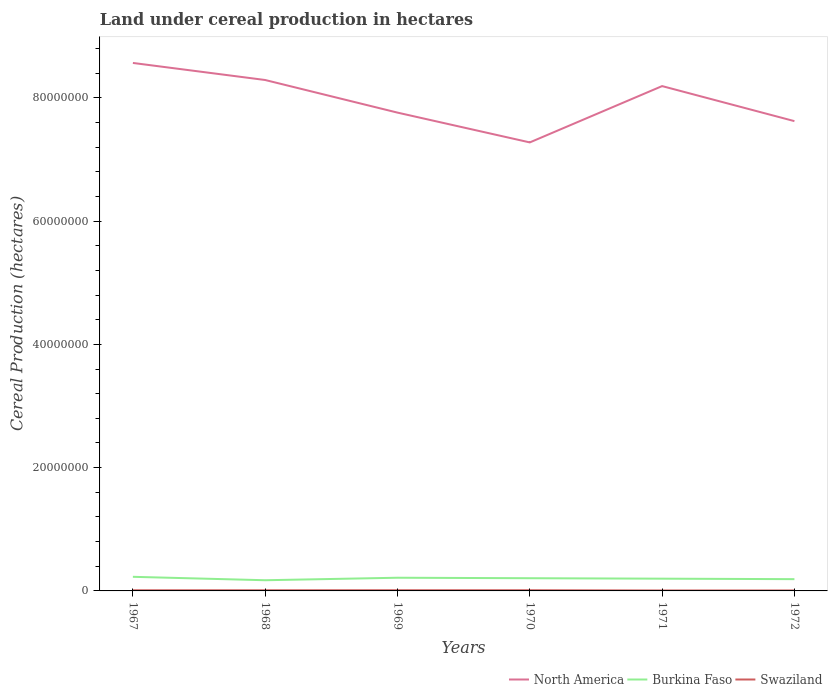Is the number of lines equal to the number of legend labels?
Give a very brief answer. Yes. Across all years, what is the maximum land under cereal production in Burkina Faso?
Your answer should be very brief. 1.73e+06. What is the total land under cereal production in Swaziland in the graph?
Ensure brevity in your answer.  4.04e+04. What is the difference between the highest and the second highest land under cereal production in North America?
Your answer should be compact. 1.29e+07. What is the difference between the highest and the lowest land under cereal production in North America?
Your answer should be very brief. 3. How many lines are there?
Give a very brief answer. 3. How many years are there in the graph?
Offer a terse response. 6. Are the values on the major ticks of Y-axis written in scientific E-notation?
Your response must be concise. No. Does the graph contain grids?
Make the answer very short. No. How many legend labels are there?
Make the answer very short. 3. What is the title of the graph?
Keep it short and to the point. Land under cereal production in hectares. What is the label or title of the Y-axis?
Keep it short and to the point. Cereal Production (hectares). What is the Cereal Production (hectares) in North America in 1967?
Your answer should be very brief. 8.57e+07. What is the Cereal Production (hectares) of Burkina Faso in 1967?
Your response must be concise. 2.29e+06. What is the Cereal Production (hectares) in Swaziland in 1967?
Make the answer very short. 1.03e+05. What is the Cereal Production (hectares) of North America in 1968?
Offer a very short reply. 8.29e+07. What is the Cereal Production (hectares) of Burkina Faso in 1968?
Offer a terse response. 1.73e+06. What is the Cereal Production (hectares) in Swaziland in 1968?
Make the answer very short. 1.07e+05. What is the Cereal Production (hectares) in North America in 1969?
Keep it short and to the point. 7.76e+07. What is the Cereal Production (hectares) in Burkina Faso in 1969?
Offer a very short reply. 2.14e+06. What is the Cereal Production (hectares) in Swaziland in 1969?
Make the answer very short. 1.11e+05. What is the Cereal Production (hectares) in North America in 1970?
Offer a terse response. 7.28e+07. What is the Cereal Production (hectares) of Burkina Faso in 1970?
Provide a succinct answer. 2.06e+06. What is the Cereal Production (hectares) of Swaziland in 1970?
Make the answer very short. 1.12e+05. What is the Cereal Production (hectares) of North America in 1971?
Provide a succinct answer. 8.19e+07. What is the Cereal Production (hectares) in Burkina Faso in 1971?
Make the answer very short. 1.99e+06. What is the Cereal Production (hectares) in Swaziland in 1971?
Ensure brevity in your answer.  7.19e+04. What is the Cereal Production (hectares) of North America in 1972?
Your answer should be compact. 7.62e+07. What is the Cereal Production (hectares) of Burkina Faso in 1972?
Provide a short and direct response. 1.91e+06. What is the Cereal Production (hectares) of Swaziland in 1972?
Offer a terse response. 7.41e+04. Across all years, what is the maximum Cereal Production (hectares) of North America?
Provide a short and direct response. 8.57e+07. Across all years, what is the maximum Cereal Production (hectares) in Burkina Faso?
Offer a terse response. 2.29e+06. Across all years, what is the maximum Cereal Production (hectares) in Swaziland?
Keep it short and to the point. 1.12e+05. Across all years, what is the minimum Cereal Production (hectares) of North America?
Keep it short and to the point. 7.28e+07. Across all years, what is the minimum Cereal Production (hectares) of Burkina Faso?
Ensure brevity in your answer.  1.73e+06. Across all years, what is the minimum Cereal Production (hectares) in Swaziland?
Give a very brief answer. 7.19e+04. What is the total Cereal Production (hectares) in North America in the graph?
Your response must be concise. 4.77e+08. What is the total Cereal Production (hectares) in Burkina Faso in the graph?
Provide a succinct answer. 1.21e+07. What is the total Cereal Production (hectares) of Swaziland in the graph?
Provide a succinct answer. 5.80e+05. What is the difference between the Cereal Production (hectares) of North America in 1967 and that in 1968?
Offer a terse response. 2.77e+06. What is the difference between the Cereal Production (hectares) of Burkina Faso in 1967 and that in 1968?
Keep it short and to the point. 5.55e+05. What is the difference between the Cereal Production (hectares) in Swaziland in 1967 and that in 1968?
Make the answer very short. -4171. What is the difference between the Cereal Production (hectares) of North America in 1967 and that in 1969?
Offer a very short reply. 8.06e+06. What is the difference between the Cereal Production (hectares) in Burkina Faso in 1967 and that in 1969?
Provide a short and direct response. 1.48e+05. What is the difference between the Cereal Production (hectares) of Swaziland in 1967 and that in 1969?
Offer a terse response. -7265. What is the difference between the Cereal Production (hectares) in North America in 1967 and that in 1970?
Offer a terse response. 1.29e+07. What is the difference between the Cereal Production (hectares) in Burkina Faso in 1967 and that in 1970?
Your answer should be compact. 2.27e+05. What is the difference between the Cereal Production (hectares) in Swaziland in 1967 and that in 1970?
Ensure brevity in your answer.  -8963. What is the difference between the Cereal Production (hectares) in North America in 1967 and that in 1971?
Make the answer very short. 3.75e+06. What is the difference between the Cereal Production (hectares) of Burkina Faso in 1967 and that in 1971?
Give a very brief answer. 3.00e+05. What is the difference between the Cereal Production (hectares) in Swaziland in 1967 and that in 1971?
Your response must be concise. 3.14e+04. What is the difference between the Cereal Production (hectares) of North America in 1967 and that in 1972?
Offer a terse response. 9.44e+06. What is the difference between the Cereal Production (hectares) in Burkina Faso in 1967 and that in 1972?
Your answer should be compact. 3.80e+05. What is the difference between the Cereal Production (hectares) of Swaziland in 1967 and that in 1972?
Your response must be concise. 2.92e+04. What is the difference between the Cereal Production (hectares) of North America in 1968 and that in 1969?
Give a very brief answer. 5.29e+06. What is the difference between the Cereal Production (hectares) in Burkina Faso in 1968 and that in 1969?
Offer a very short reply. -4.07e+05. What is the difference between the Cereal Production (hectares) of Swaziland in 1968 and that in 1969?
Offer a very short reply. -3094. What is the difference between the Cereal Production (hectares) in North America in 1968 and that in 1970?
Provide a succinct answer. 1.01e+07. What is the difference between the Cereal Production (hectares) of Burkina Faso in 1968 and that in 1970?
Your response must be concise. -3.29e+05. What is the difference between the Cereal Production (hectares) in Swaziland in 1968 and that in 1970?
Make the answer very short. -4792. What is the difference between the Cereal Production (hectares) in North America in 1968 and that in 1971?
Offer a very short reply. 9.86e+05. What is the difference between the Cereal Production (hectares) in Burkina Faso in 1968 and that in 1971?
Ensure brevity in your answer.  -2.55e+05. What is the difference between the Cereal Production (hectares) in Swaziland in 1968 and that in 1971?
Your answer should be very brief. 3.56e+04. What is the difference between the Cereal Production (hectares) in North America in 1968 and that in 1972?
Provide a short and direct response. 6.67e+06. What is the difference between the Cereal Production (hectares) in Burkina Faso in 1968 and that in 1972?
Offer a terse response. -1.75e+05. What is the difference between the Cereal Production (hectares) of Swaziland in 1968 and that in 1972?
Make the answer very short. 3.34e+04. What is the difference between the Cereal Production (hectares) in North America in 1969 and that in 1970?
Make the answer very short. 4.83e+06. What is the difference between the Cereal Production (hectares) of Burkina Faso in 1969 and that in 1970?
Your response must be concise. 7.86e+04. What is the difference between the Cereal Production (hectares) of Swaziland in 1969 and that in 1970?
Offer a very short reply. -1698. What is the difference between the Cereal Production (hectares) in North America in 1969 and that in 1971?
Give a very brief answer. -4.30e+06. What is the difference between the Cereal Production (hectares) in Burkina Faso in 1969 and that in 1971?
Give a very brief answer. 1.52e+05. What is the difference between the Cereal Production (hectares) of Swaziland in 1969 and that in 1971?
Provide a succinct answer. 3.87e+04. What is the difference between the Cereal Production (hectares) in North America in 1969 and that in 1972?
Ensure brevity in your answer.  1.38e+06. What is the difference between the Cereal Production (hectares) in Burkina Faso in 1969 and that in 1972?
Offer a very short reply. 2.32e+05. What is the difference between the Cereal Production (hectares) of Swaziland in 1969 and that in 1972?
Your response must be concise. 3.65e+04. What is the difference between the Cereal Production (hectares) of North America in 1970 and that in 1971?
Keep it short and to the point. -9.14e+06. What is the difference between the Cereal Production (hectares) in Burkina Faso in 1970 and that in 1971?
Give a very brief answer. 7.38e+04. What is the difference between the Cereal Production (hectares) in Swaziland in 1970 and that in 1971?
Ensure brevity in your answer.  4.04e+04. What is the difference between the Cereal Production (hectares) in North America in 1970 and that in 1972?
Offer a terse response. -3.45e+06. What is the difference between the Cereal Production (hectares) in Burkina Faso in 1970 and that in 1972?
Your response must be concise. 1.53e+05. What is the difference between the Cereal Production (hectares) in Swaziland in 1970 and that in 1972?
Offer a very short reply. 3.82e+04. What is the difference between the Cereal Production (hectares) in North America in 1971 and that in 1972?
Offer a terse response. 5.68e+06. What is the difference between the Cereal Production (hectares) of Burkina Faso in 1971 and that in 1972?
Your response must be concise. 7.95e+04. What is the difference between the Cereal Production (hectares) in Swaziland in 1971 and that in 1972?
Your response must be concise. -2229. What is the difference between the Cereal Production (hectares) in North America in 1967 and the Cereal Production (hectares) in Burkina Faso in 1968?
Provide a succinct answer. 8.39e+07. What is the difference between the Cereal Production (hectares) in North America in 1967 and the Cereal Production (hectares) in Swaziland in 1968?
Your answer should be very brief. 8.55e+07. What is the difference between the Cereal Production (hectares) of Burkina Faso in 1967 and the Cereal Production (hectares) of Swaziland in 1968?
Make the answer very short. 2.18e+06. What is the difference between the Cereal Production (hectares) in North America in 1967 and the Cereal Production (hectares) in Burkina Faso in 1969?
Ensure brevity in your answer.  8.35e+07. What is the difference between the Cereal Production (hectares) of North America in 1967 and the Cereal Production (hectares) of Swaziland in 1969?
Your answer should be very brief. 8.55e+07. What is the difference between the Cereal Production (hectares) of Burkina Faso in 1967 and the Cereal Production (hectares) of Swaziland in 1969?
Your answer should be very brief. 2.18e+06. What is the difference between the Cereal Production (hectares) of North America in 1967 and the Cereal Production (hectares) of Burkina Faso in 1970?
Your answer should be compact. 8.36e+07. What is the difference between the Cereal Production (hectares) in North America in 1967 and the Cereal Production (hectares) in Swaziland in 1970?
Make the answer very short. 8.55e+07. What is the difference between the Cereal Production (hectares) in Burkina Faso in 1967 and the Cereal Production (hectares) in Swaziland in 1970?
Offer a terse response. 2.18e+06. What is the difference between the Cereal Production (hectares) in North America in 1967 and the Cereal Production (hectares) in Burkina Faso in 1971?
Keep it short and to the point. 8.37e+07. What is the difference between the Cereal Production (hectares) in North America in 1967 and the Cereal Production (hectares) in Swaziland in 1971?
Provide a short and direct response. 8.56e+07. What is the difference between the Cereal Production (hectares) in Burkina Faso in 1967 and the Cereal Production (hectares) in Swaziland in 1971?
Offer a very short reply. 2.22e+06. What is the difference between the Cereal Production (hectares) of North America in 1967 and the Cereal Production (hectares) of Burkina Faso in 1972?
Provide a short and direct response. 8.37e+07. What is the difference between the Cereal Production (hectares) of North America in 1967 and the Cereal Production (hectares) of Swaziland in 1972?
Provide a short and direct response. 8.56e+07. What is the difference between the Cereal Production (hectares) in Burkina Faso in 1967 and the Cereal Production (hectares) in Swaziland in 1972?
Your answer should be very brief. 2.21e+06. What is the difference between the Cereal Production (hectares) in North America in 1968 and the Cereal Production (hectares) in Burkina Faso in 1969?
Your answer should be very brief. 8.07e+07. What is the difference between the Cereal Production (hectares) in North America in 1968 and the Cereal Production (hectares) in Swaziland in 1969?
Provide a short and direct response. 8.28e+07. What is the difference between the Cereal Production (hectares) in Burkina Faso in 1968 and the Cereal Production (hectares) in Swaziland in 1969?
Offer a very short reply. 1.62e+06. What is the difference between the Cereal Production (hectares) of North America in 1968 and the Cereal Production (hectares) of Burkina Faso in 1970?
Give a very brief answer. 8.08e+07. What is the difference between the Cereal Production (hectares) in North America in 1968 and the Cereal Production (hectares) in Swaziland in 1970?
Offer a terse response. 8.28e+07. What is the difference between the Cereal Production (hectares) of Burkina Faso in 1968 and the Cereal Production (hectares) of Swaziland in 1970?
Offer a very short reply. 1.62e+06. What is the difference between the Cereal Production (hectares) of North America in 1968 and the Cereal Production (hectares) of Burkina Faso in 1971?
Offer a very short reply. 8.09e+07. What is the difference between the Cereal Production (hectares) of North America in 1968 and the Cereal Production (hectares) of Swaziland in 1971?
Your answer should be compact. 8.28e+07. What is the difference between the Cereal Production (hectares) in Burkina Faso in 1968 and the Cereal Production (hectares) in Swaziland in 1971?
Offer a terse response. 1.66e+06. What is the difference between the Cereal Production (hectares) of North America in 1968 and the Cereal Production (hectares) of Burkina Faso in 1972?
Make the answer very short. 8.10e+07. What is the difference between the Cereal Production (hectares) of North America in 1968 and the Cereal Production (hectares) of Swaziland in 1972?
Your answer should be very brief. 8.28e+07. What is the difference between the Cereal Production (hectares) in Burkina Faso in 1968 and the Cereal Production (hectares) in Swaziland in 1972?
Give a very brief answer. 1.66e+06. What is the difference between the Cereal Production (hectares) in North America in 1969 and the Cereal Production (hectares) in Burkina Faso in 1970?
Offer a terse response. 7.55e+07. What is the difference between the Cereal Production (hectares) in North America in 1969 and the Cereal Production (hectares) in Swaziland in 1970?
Ensure brevity in your answer.  7.75e+07. What is the difference between the Cereal Production (hectares) of Burkina Faso in 1969 and the Cereal Production (hectares) of Swaziland in 1970?
Your answer should be very brief. 2.03e+06. What is the difference between the Cereal Production (hectares) of North America in 1969 and the Cereal Production (hectares) of Burkina Faso in 1971?
Offer a terse response. 7.56e+07. What is the difference between the Cereal Production (hectares) in North America in 1969 and the Cereal Production (hectares) in Swaziland in 1971?
Your response must be concise. 7.75e+07. What is the difference between the Cereal Production (hectares) in Burkina Faso in 1969 and the Cereal Production (hectares) in Swaziland in 1971?
Your answer should be very brief. 2.07e+06. What is the difference between the Cereal Production (hectares) of North America in 1969 and the Cereal Production (hectares) of Burkina Faso in 1972?
Provide a succinct answer. 7.57e+07. What is the difference between the Cereal Production (hectares) of North America in 1969 and the Cereal Production (hectares) of Swaziland in 1972?
Your answer should be compact. 7.75e+07. What is the difference between the Cereal Production (hectares) of Burkina Faso in 1969 and the Cereal Production (hectares) of Swaziland in 1972?
Offer a very short reply. 2.07e+06. What is the difference between the Cereal Production (hectares) of North America in 1970 and the Cereal Production (hectares) of Burkina Faso in 1971?
Offer a very short reply. 7.08e+07. What is the difference between the Cereal Production (hectares) in North America in 1970 and the Cereal Production (hectares) in Swaziland in 1971?
Ensure brevity in your answer.  7.27e+07. What is the difference between the Cereal Production (hectares) of Burkina Faso in 1970 and the Cereal Production (hectares) of Swaziland in 1971?
Provide a short and direct response. 1.99e+06. What is the difference between the Cereal Production (hectares) in North America in 1970 and the Cereal Production (hectares) in Burkina Faso in 1972?
Ensure brevity in your answer.  7.09e+07. What is the difference between the Cereal Production (hectares) in North America in 1970 and the Cereal Production (hectares) in Swaziland in 1972?
Provide a short and direct response. 7.27e+07. What is the difference between the Cereal Production (hectares) of Burkina Faso in 1970 and the Cereal Production (hectares) of Swaziland in 1972?
Provide a succinct answer. 1.99e+06. What is the difference between the Cereal Production (hectares) of North America in 1971 and the Cereal Production (hectares) of Burkina Faso in 1972?
Offer a very short reply. 8.00e+07. What is the difference between the Cereal Production (hectares) of North America in 1971 and the Cereal Production (hectares) of Swaziland in 1972?
Provide a short and direct response. 8.18e+07. What is the difference between the Cereal Production (hectares) in Burkina Faso in 1971 and the Cereal Production (hectares) in Swaziland in 1972?
Your response must be concise. 1.91e+06. What is the average Cereal Production (hectares) of North America per year?
Your response must be concise. 7.95e+07. What is the average Cereal Production (hectares) of Burkina Faso per year?
Make the answer very short. 2.02e+06. What is the average Cereal Production (hectares) of Swaziland per year?
Your response must be concise. 9.66e+04. In the year 1967, what is the difference between the Cereal Production (hectares) in North America and Cereal Production (hectares) in Burkina Faso?
Give a very brief answer. 8.34e+07. In the year 1967, what is the difference between the Cereal Production (hectares) of North America and Cereal Production (hectares) of Swaziland?
Your response must be concise. 8.55e+07. In the year 1967, what is the difference between the Cereal Production (hectares) in Burkina Faso and Cereal Production (hectares) in Swaziland?
Offer a terse response. 2.19e+06. In the year 1968, what is the difference between the Cereal Production (hectares) in North America and Cereal Production (hectares) in Burkina Faso?
Give a very brief answer. 8.11e+07. In the year 1968, what is the difference between the Cereal Production (hectares) of North America and Cereal Production (hectares) of Swaziland?
Offer a very short reply. 8.28e+07. In the year 1968, what is the difference between the Cereal Production (hectares) of Burkina Faso and Cereal Production (hectares) of Swaziland?
Provide a succinct answer. 1.63e+06. In the year 1969, what is the difference between the Cereal Production (hectares) of North America and Cereal Production (hectares) of Burkina Faso?
Your answer should be very brief. 7.55e+07. In the year 1969, what is the difference between the Cereal Production (hectares) in North America and Cereal Production (hectares) in Swaziland?
Provide a succinct answer. 7.75e+07. In the year 1969, what is the difference between the Cereal Production (hectares) in Burkina Faso and Cereal Production (hectares) in Swaziland?
Provide a short and direct response. 2.03e+06. In the year 1970, what is the difference between the Cereal Production (hectares) of North America and Cereal Production (hectares) of Burkina Faso?
Your answer should be compact. 7.07e+07. In the year 1970, what is the difference between the Cereal Production (hectares) of North America and Cereal Production (hectares) of Swaziland?
Provide a succinct answer. 7.26e+07. In the year 1970, what is the difference between the Cereal Production (hectares) of Burkina Faso and Cereal Production (hectares) of Swaziland?
Make the answer very short. 1.95e+06. In the year 1971, what is the difference between the Cereal Production (hectares) of North America and Cereal Production (hectares) of Burkina Faso?
Offer a terse response. 7.99e+07. In the year 1971, what is the difference between the Cereal Production (hectares) in North America and Cereal Production (hectares) in Swaziland?
Keep it short and to the point. 8.18e+07. In the year 1971, what is the difference between the Cereal Production (hectares) of Burkina Faso and Cereal Production (hectares) of Swaziland?
Offer a terse response. 1.92e+06. In the year 1972, what is the difference between the Cereal Production (hectares) of North America and Cereal Production (hectares) of Burkina Faso?
Make the answer very short. 7.43e+07. In the year 1972, what is the difference between the Cereal Production (hectares) of North America and Cereal Production (hectares) of Swaziland?
Provide a succinct answer. 7.61e+07. In the year 1972, what is the difference between the Cereal Production (hectares) in Burkina Faso and Cereal Production (hectares) in Swaziland?
Offer a terse response. 1.83e+06. What is the ratio of the Cereal Production (hectares) in North America in 1967 to that in 1968?
Your answer should be very brief. 1.03. What is the ratio of the Cereal Production (hectares) in Burkina Faso in 1967 to that in 1968?
Give a very brief answer. 1.32. What is the ratio of the Cereal Production (hectares) in Swaziland in 1967 to that in 1968?
Offer a terse response. 0.96. What is the ratio of the Cereal Production (hectares) of North America in 1967 to that in 1969?
Your answer should be very brief. 1.1. What is the ratio of the Cereal Production (hectares) of Burkina Faso in 1967 to that in 1969?
Your response must be concise. 1.07. What is the ratio of the Cereal Production (hectares) of Swaziland in 1967 to that in 1969?
Offer a terse response. 0.93. What is the ratio of the Cereal Production (hectares) of North America in 1967 to that in 1970?
Your answer should be compact. 1.18. What is the ratio of the Cereal Production (hectares) in Burkina Faso in 1967 to that in 1970?
Your response must be concise. 1.11. What is the ratio of the Cereal Production (hectares) in Swaziland in 1967 to that in 1970?
Your answer should be compact. 0.92. What is the ratio of the Cereal Production (hectares) of North America in 1967 to that in 1971?
Offer a very short reply. 1.05. What is the ratio of the Cereal Production (hectares) in Burkina Faso in 1967 to that in 1971?
Your answer should be compact. 1.15. What is the ratio of the Cereal Production (hectares) in Swaziland in 1967 to that in 1971?
Offer a very short reply. 1.44. What is the ratio of the Cereal Production (hectares) of North America in 1967 to that in 1972?
Provide a short and direct response. 1.12. What is the ratio of the Cereal Production (hectares) of Burkina Faso in 1967 to that in 1972?
Offer a terse response. 1.2. What is the ratio of the Cereal Production (hectares) of Swaziland in 1967 to that in 1972?
Offer a very short reply. 1.39. What is the ratio of the Cereal Production (hectares) in North America in 1968 to that in 1969?
Offer a terse response. 1.07. What is the ratio of the Cereal Production (hectares) in Burkina Faso in 1968 to that in 1969?
Offer a very short reply. 0.81. What is the ratio of the Cereal Production (hectares) of North America in 1968 to that in 1970?
Ensure brevity in your answer.  1.14. What is the ratio of the Cereal Production (hectares) of Burkina Faso in 1968 to that in 1970?
Offer a terse response. 0.84. What is the ratio of the Cereal Production (hectares) of Swaziland in 1968 to that in 1970?
Provide a short and direct response. 0.96. What is the ratio of the Cereal Production (hectares) of North America in 1968 to that in 1971?
Provide a succinct answer. 1.01. What is the ratio of the Cereal Production (hectares) of Burkina Faso in 1968 to that in 1971?
Provide a succinct answer. 0.87. What is the ratio of the Cereal Production (hectares) of Swaziland in 1968 to that in 1971?
Give a very brief answer. 1.5. What is the ratio of the Cereal Production (hectares) of North America in 1968 to that in 1972?
Ensure brevity in your answer.  1.09. What is the ratio of the Cereal Production (hectares) of Burkina Faso in 1968 to that in 1972?
Your answer should be compact. 0.91. What is the ratio of the Cereal Production (hectares) of Swaziland in 1968 to that in 1972?
Keep it short and to the point. 1.45. What is the ratio of the Cereal Production (hectares) in North America in 1969 to that in 1970?
Keep it short and to the point. 1.07. What is the ratio of the Cereal Production (hectares) in Burkina Faso in 1969 to that in 1970?
Ensure brevity in your answer.  1.04. What is the ratio of the Cereal Production (hectares) in Swaziland in 1969 to that in 1970?
Your answer should be very brief. 0.98. What is the ratio of the Cereal Production (hectares) of North America in 1969 to that in 1971?
Ensure brevity in your answer.  0.95. What is the ratio of the Cereal Production (hectares) in Burkina Faso in 1969 to that in 1971?
Make the answer very short. 1.08. What is the ratio of the Cereal Production (hectares) in Swaziland in 1969 to that in 1971?
Make the answer very short. 1.54. What is the ratio of the Cereal Production (hectares) in North America in 1969 to that in 1972?
Give a very brief answer. 1.02. What is the ratio of the Cereal Production (hectares) of Burkina Faso in 1969 to that in 1972?
Offer a terse response. 1.12. What is the ratio of the Cereal Production (hectares) in Swaziland in 1969 to that in 1972?
Your response must be concise. 1.49. What is the ratio of the Cereal Production (hectares) in North America in 1970 to that in 1971?
Give a very brief answer. 0.89. What is the ratio of the Cereal Production (hectares) in Burkina Faso in 1970 to that in 1971?
Your answer should be very brief. 1.04. What is the ratio of the Cereal Production (hectares) in Swaziland in 1970 to that in 1971?
Your response must be concise. 1.56. What is the ratio of the Cereal Production (hectares) of North America in 1970 to that in 1972?
Provide a short and direct response. 0.95. What is the ratio of the Cereal Production (hectares) of Burkina Faso in 1970 to that in 1972?
Your response must be concise. 1.08. What is the ratio of the Cereal Production (hectares) in Swaziland in 1970 to that in 1972?
Provide a short and direct response. 1.52. What is the ratio of the Cereal Production (hectares) of North America in 1971 to that in 1972?
Ensure brevity in your answer.  1.07. What is the ratio of the Cereal Production (hectares) in Burkina Faso in 1971 to that in 1972?
Your answer should be very brief. 1.04. What is the ratio of the Cereal Production (hectares) of Swaziland in 1971 to that in 1972?
Make the answer very short. 0.97. What is the difference between the highest and the second highest Cereal Production (hectares) of North America?
Provide a short and direct response. 2.77e+06. What is the difference between the highest and the second highest Cereal Production (hectares) in Burkina Faso?
Provide a succinct answer. 1.48e+05. What is the difference between the highest and the second highest Cereal Production (hectares) in Swaziland?
Offer a terse response. 1698. What is the difference between the highest and the lowest Cereal Production (hectares) in North America?
Offer a very short reply. 1.29e+07. What is the difference between the highest and the lowest Cereal Production (hectares) in Burkina Faso?
Ensure brevity in your answer.  5.55e+05. What is the difference between the highest and the lowest Cereal Production (hectares) in Swaziland?
Your answer should be very brief. 4.04e+04. 